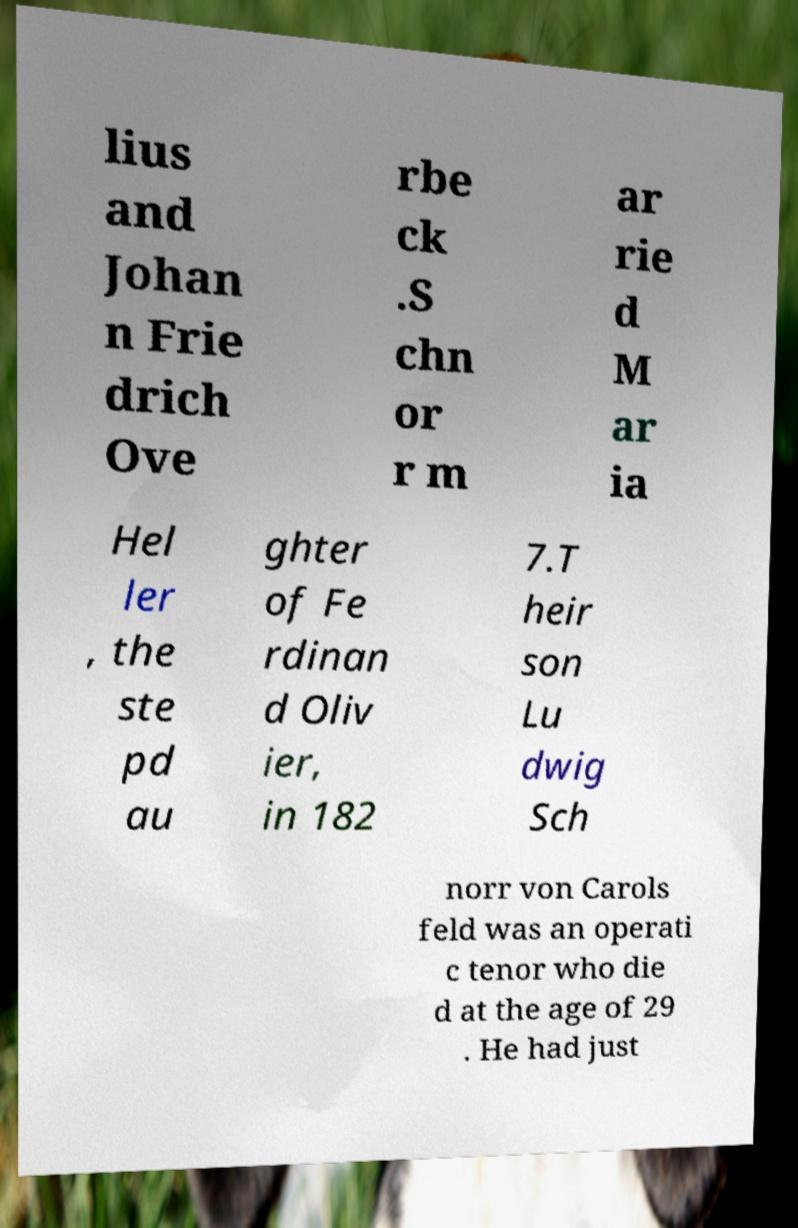Can you read and provide the text displayed in the image?This photo seems to have some interesting text. Can you extract and type it out for me? lius and Johan n Frie drich Ove rbe ck .S chn or r m ar rie d M ar ia Hel ler , the ste pd au ghter of Fe rdinan d Oliv ier, in 182 7.T heir son Lu dwig Sch norr von Carols feld was an operati c tenor who die d at the age of 29 . He had just 